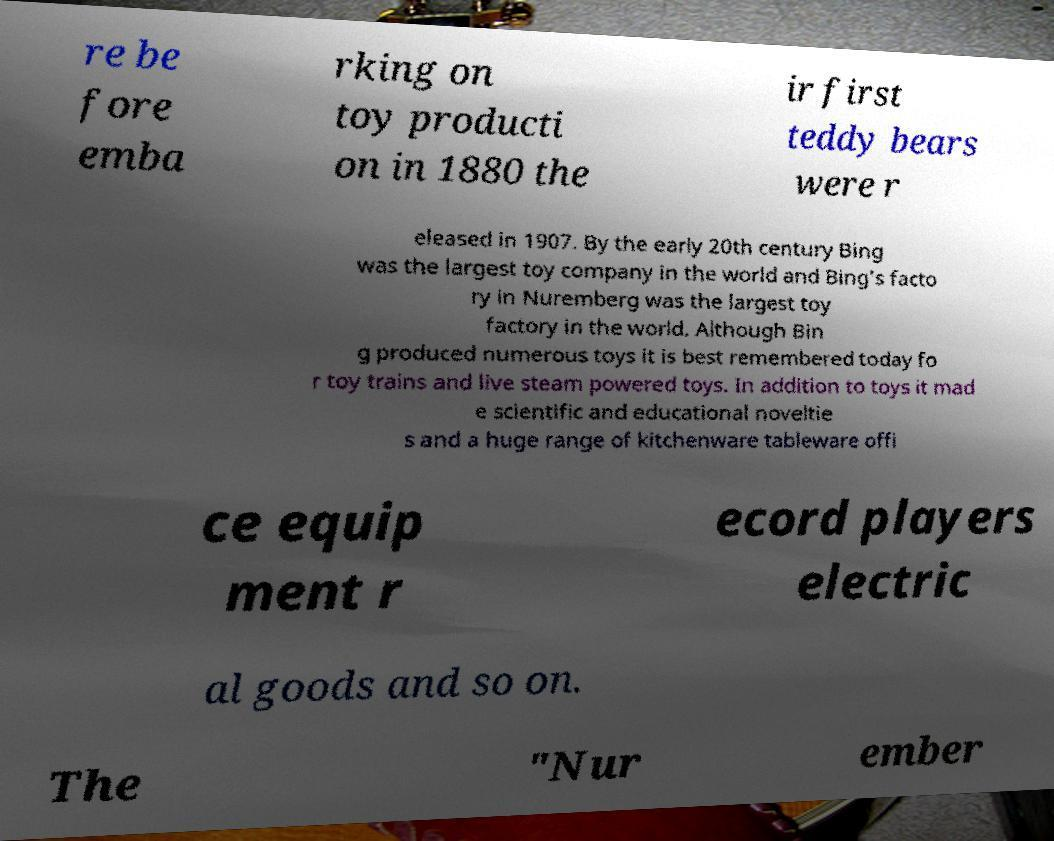I need the written content from this picture converted into text. Can you do that? re be fore emba rking on toy producti on in 1880 the ir first teddy bears were r eleased in 1907. By the early 20th century Bing was the largest toy company in the world and Bing's facto ry in Nuremberg was the largest toy factory in the world. Although Bin g produced numerous toys it is best remembered today fo r toy trains and live steam powered toys. In addition to toys it mad e scientific and educational noveltie s and a huge range of kitchenware tableware offi ce equip ment r ecord players electric al goods and so on. The "Nur ember 